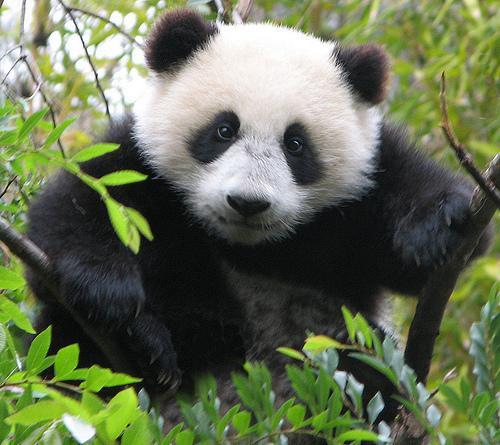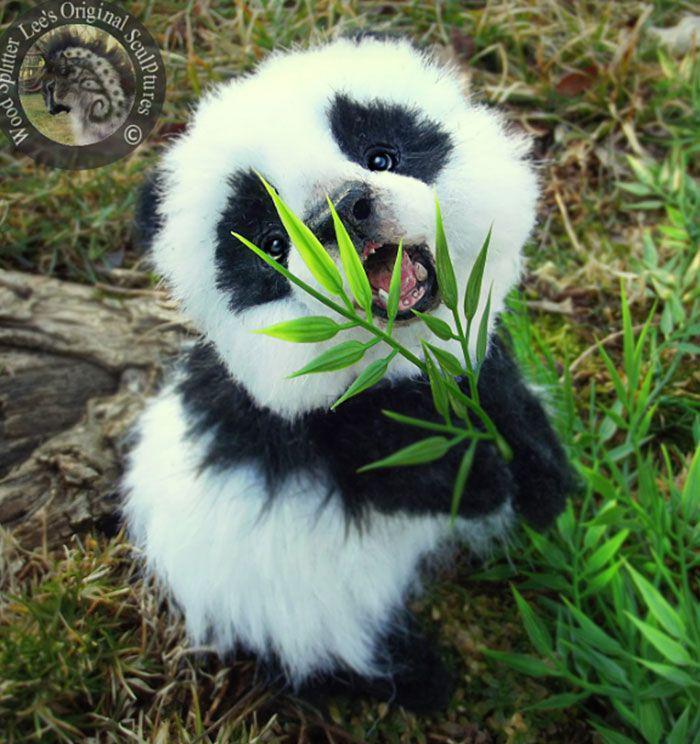The first image is the image on the left, the second image is the image on the right. Analyze the images presented: Is the assertion "The right image shows one panda, which is posed with open mouth to munch on a green stem." valid? Answer yes or no. Yes. The first image is the image on the left, the second image is the image on the right. Examine the images to the left and right. Is the description "An image contains at lest four pandas." accurate? Answer yes or no. No. 